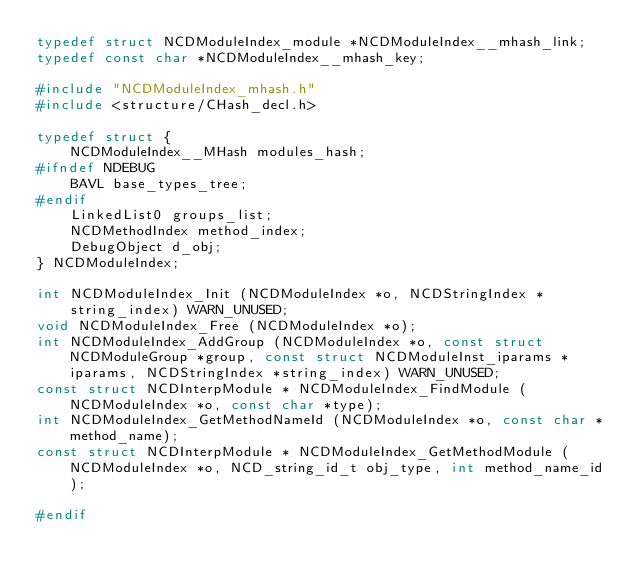<code> <loc_0><loc_0><loc_500><loc_500><_C_>typedef struct NCDModuleIndex_module *NCDModuleIndex__mhash_link;
typedef const char *NCDModuleIndex__mhash_key;

#include "NCDModuleIndex_mhash.h"
#include <structure/CHash_decl.h>

typedef struct {
    NCDModuleIndex__MHash modules_hash;
#ifndef NDEBUG
    BAVL base_types_tree;
#endif
    LinkedList0 groups_list;
    NCDMethodIndex method_index;
    DebugObject d_obj;
} NCDModuleIndex;

int NCDModuleIndex_Init (NCDModuleIndex *o, NCDStringIndex *string_index) WARN_UNUSED;
void NCDModuleIndex_Free (NCDModuleIndex *o);
int NCDModuleIndex_AddGroup (NCDModuleIndex *o, const struct NCDModuleGroup *group, const struct NCDModuleInst_iparams *iparams, NCDStringIndex *string_index) WARN_UNUSED;
const struct NCDInterpModule * NCDModuleIndex_FindModule (NCDModuleIndex *o, const char *type);
int NCDModuleIndex_GetMethodNameId (NCDModuleIndex *o, const char *method_name);
const struct NCDInterpModule * NCDModuleIndex_GetMethodModule (NCDModuleIndex *o, NCD_string_id_t obj_type, int method_name_id);

#endif
</code> 